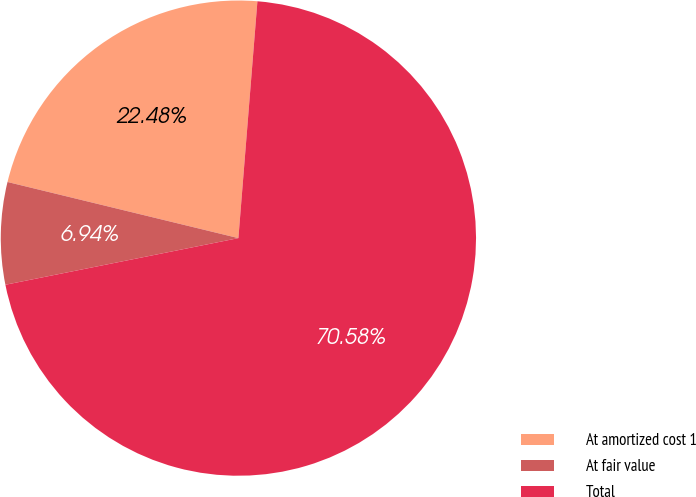Convert chart. <chart><loc_0><loc_0><loc_500><loc_500><pie_chart><fcel>At amortized cost 1<fcel>At fair value<fcel>Total<nl><fcel>22.48%<fcel>6.94%<fcel>70.58%<nl></chart> 